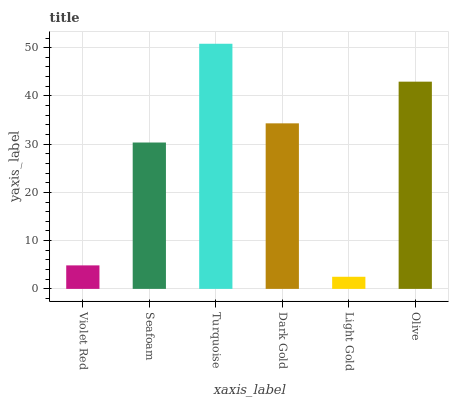Is Light Gold the minimum?
Answer yes or no. Yes. Is Turquoise the maximum?
Answer yes or no. Yes. Is Seafoam the minimum?
Answer yes or no. No. Is Seafoam the maximum?
Answer yes or no. No. Is Seafoam greater than Violet Red?
Answer yes or no. Yes. Is Violet Red less than Seafoam?
Answer yes or no. Yes. Is Violet Red greater than Seafoam?
Answer yes or no. No. Is Seafoam less than Violet Red?
Answer yes or no. No. Is Dark Gold the high median?
Answer yes or no. Yes. Is Seafoam the low median?
Answer yes or no. Yes. Is Turquoise the high median?
Answer yes or no. No. Is Light Gold the low median?
Answer yes or no. No. 